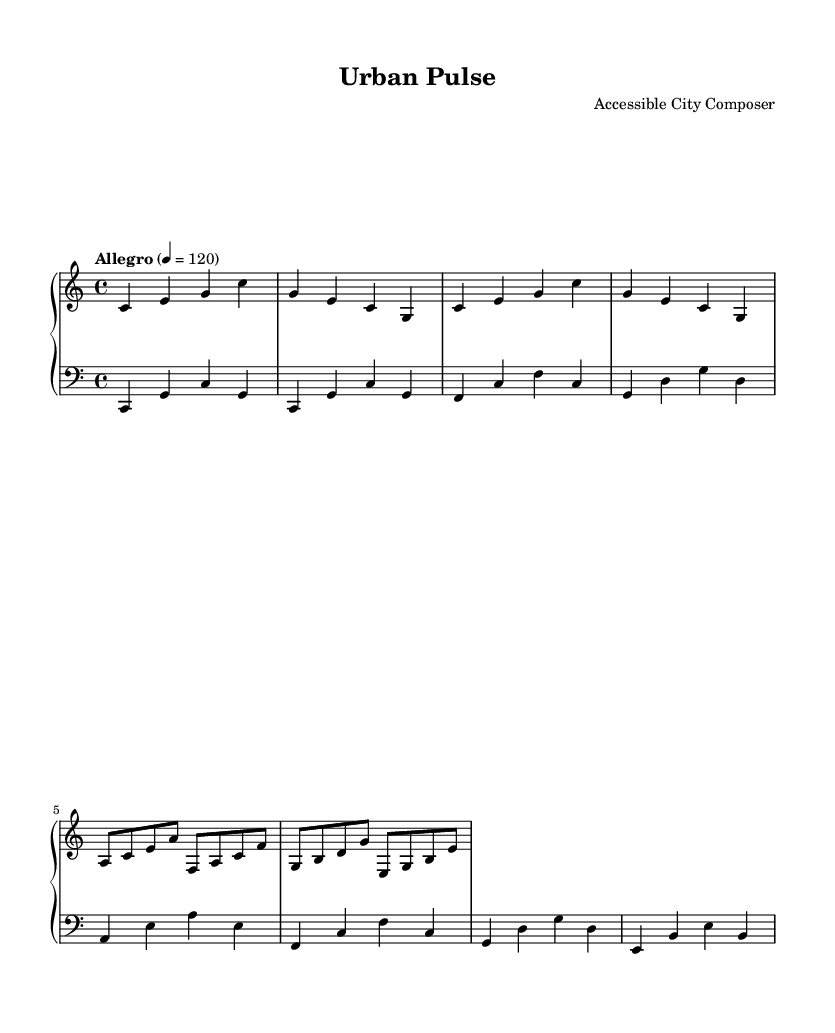what is the key signature of this music? The key signature shown in the sheet music is C major, which is indicated by the absence of sharps or flats.
Answer: C major what is the time signature of this piece? The time signature is located at the beginning of the sheet music and is noted as 4/4, meaning there are four beats in each measure.
Answer: 4/4 what is the tempo marking for this composition? The tempo marking is displayed on the sheet music, indicating the piece should be played at "Allegro," with a metronome marking of 120 beats per minute.
Answer: Allegro which musical instruments are indicated in the score? The score shows two staves, indicating it is written for piano. Thus, the instruments are specified as a right hand (treble clef) and a left hand (bass clef) for piano.
Answer: Piano how many themes are presented in the composition? The composition consists of two main themes labeled A and B. They can be identified in the notation where distinct musical phrases are repeated or varied.
Answer: Two what is the contour of the melody in Main Theme A? The melody in Main Theme A starts low, rises to higher notes, and comes back down, showcasing a wave-like contour, typically seen in minimalist music reflecting patterns.
Answer: Wave-like how do the left hand and right hand parts interact rhythmically? The left hand plays a steady harmonic foundation while the right hand presents the melodic lines, creating a contrast that reflects the complexities of urban rhythms found in public transportation systems.
Answer: Alternating 